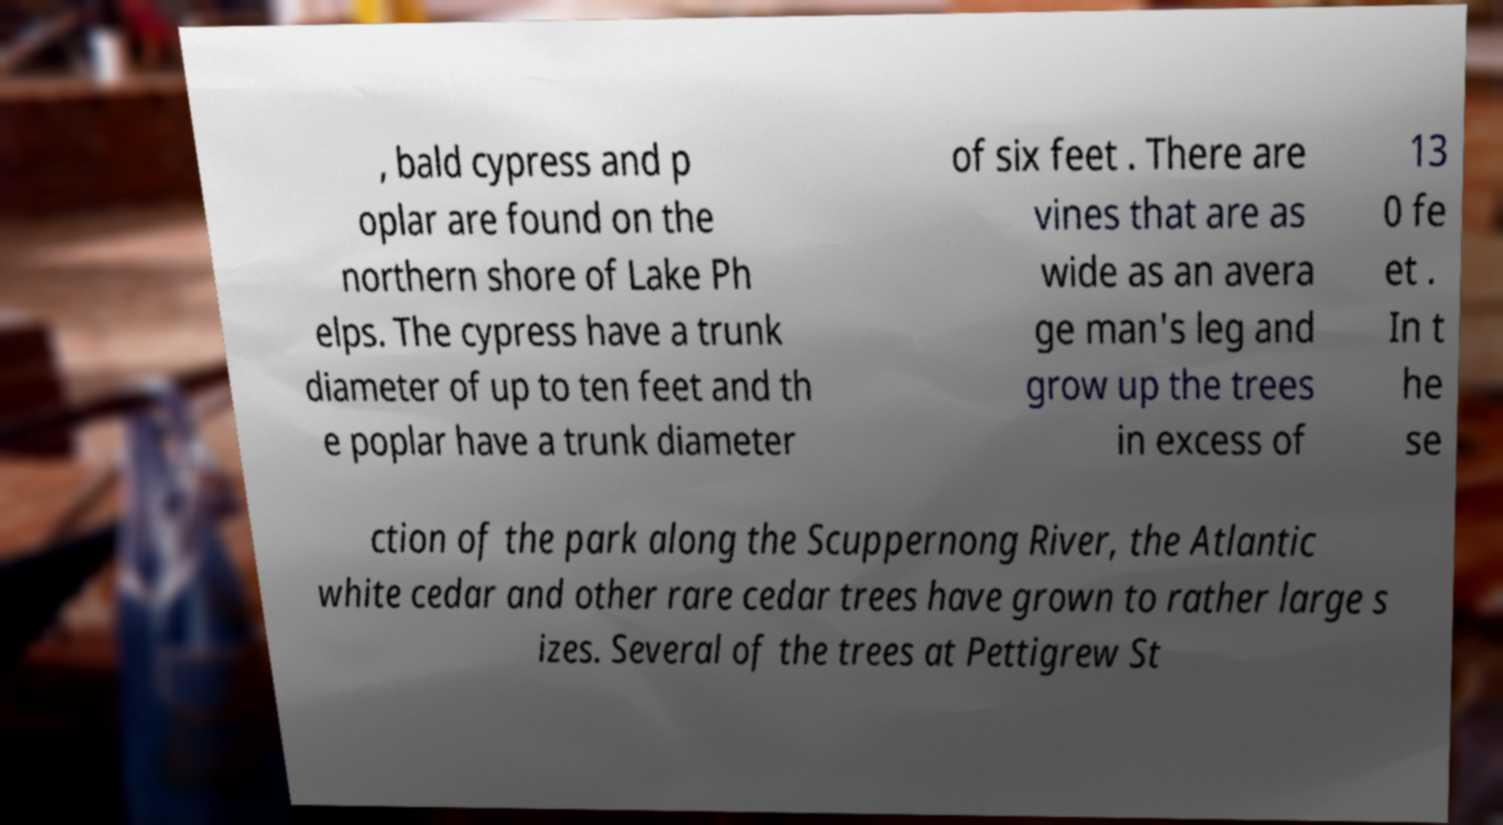Can you read and provide the text displayed in the image?This photo seems to have some interesting text. Can you extract and type it out for me? , bald cypress and p oplar are found on the northern shore of Lake Ph elps. The cypress have a trunk diameter of up to ten feet and th e poplar have a trunk diameter of six feet . There are vines that are as wide as an avera ge man's leg and grow up the trees in excess of 13 0 fe et . In t he se ction of the park along the Scuppernong River, the Atlantic white cedar and other rare cedar trees have grown to rather large s izes. Several of the trees at Pettigrew St 